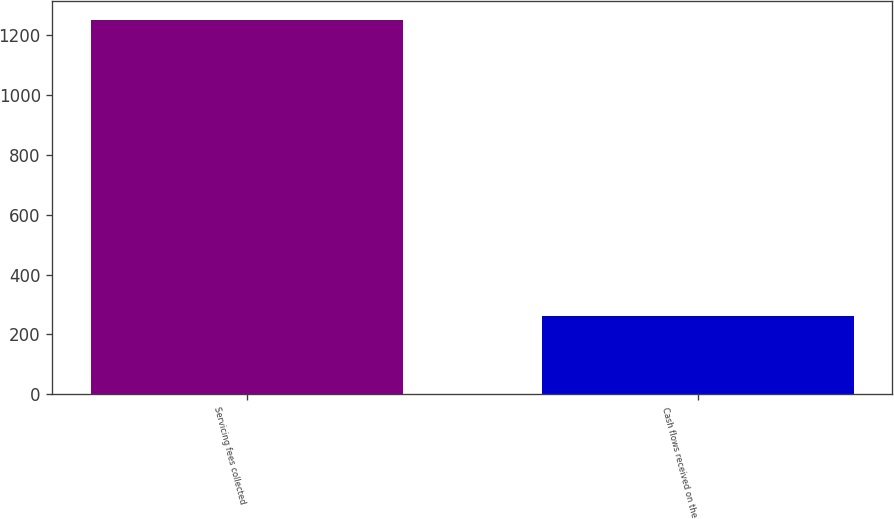Convert chart. <chart><loc_0><loc_0><loc_500><loc_500><bar_chart><fcel>Servicing fees collected<fcel>Cash flows received on the<nl><fcel>1251<fcel>261<nl></chart> 